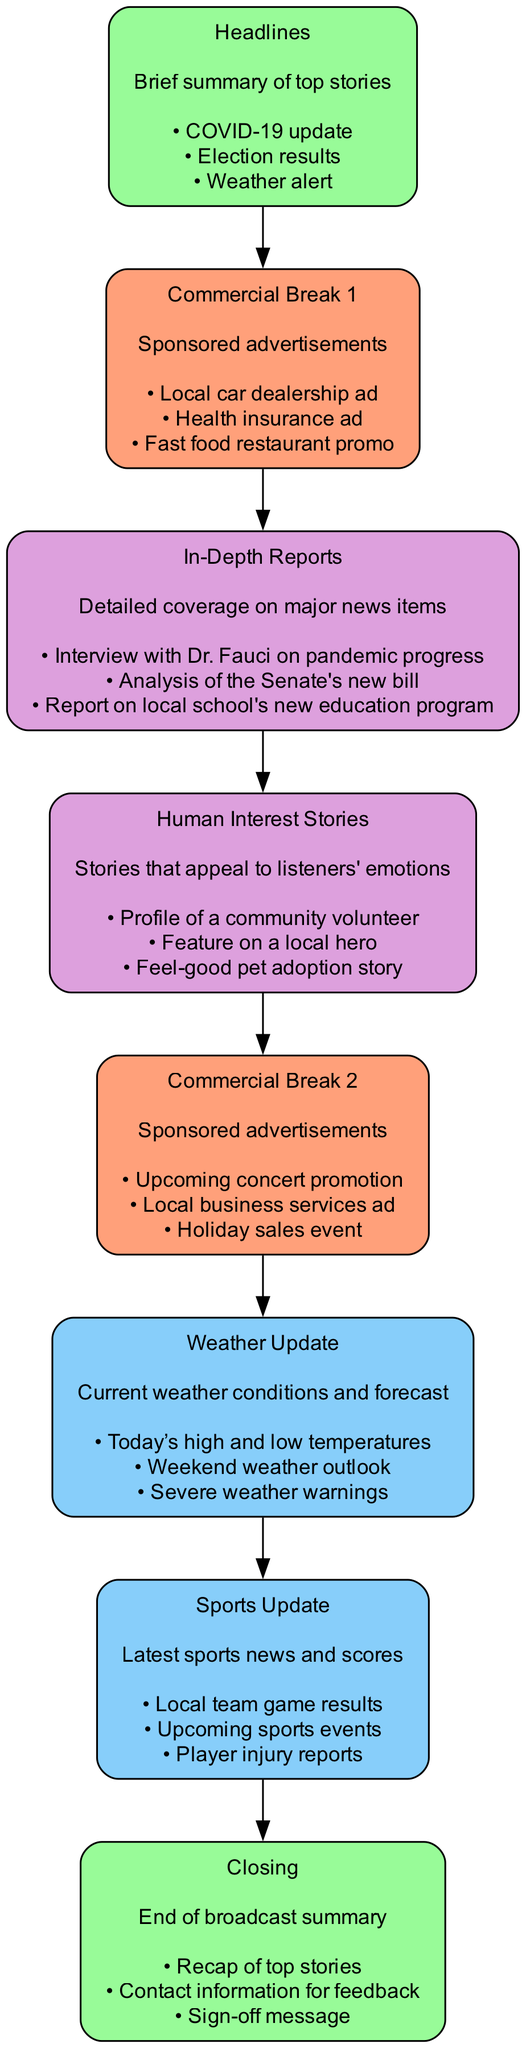What is the first section in the broadcast structure? The first section in the diagram is "Headlines". It is positioned at the top of the diagram before any other sections.
Answer: Headlines How many commercial breaks are included in the structure? The diagram lists two sections labeled "Commercial Break 1" and "Commercial Break 2", indicating there are two commercial breaks.
Answer: 2 What type of stories appeal to listeners' emotions? The diagram defines "Human Interest Stories" as the type of stories that appeal to listeners' emotions. This section emphasizes emotional connection through personal narratives.
Answer: Human Interest Stories Which section follows the "In-Depth Reports"? The diagram clearly sequences "In-Depth Reports" followed by "Human Interest Stories". The arrows indicate the direct flow from one to the next.
Answer: Human Interest Stories What color represents commercial breaks in the diagram? The commercial breaks are colored in light salmon, which distinguishes them visually from other sections. By analyzing the color scheme, we identify that both commercial break sections use this color.
Answer: Light Salmon How many examples are provided for "Weather Update"? In the "Weather Update" section, there are three listed examples of current information, such as temperatures and forecasts. Counting these indicates that there are three examples provided.
Answer: 3 Which two sections are categorized with the same color? "Weather Update" and "Sports Update" are both highlighted in light sky blue, indicating they are categorized under a similar theme. This can be inferred from the consistent use of color for these sections in the diagram.
Answer: Weather Update and Sports Update What is included in the "Closing" section? The "Closing" section summarizes the broadcast with a recap of top stories, along with contact information and a sign-off message, providing closure to the program.
Answer: Recap of top stories, contact information, sign-off message Which section discusses latest sporting events? The "Sports Update" section specifically covers the latest sports news and scores, including information on team results and player injuries.
Answer: Sports Update 